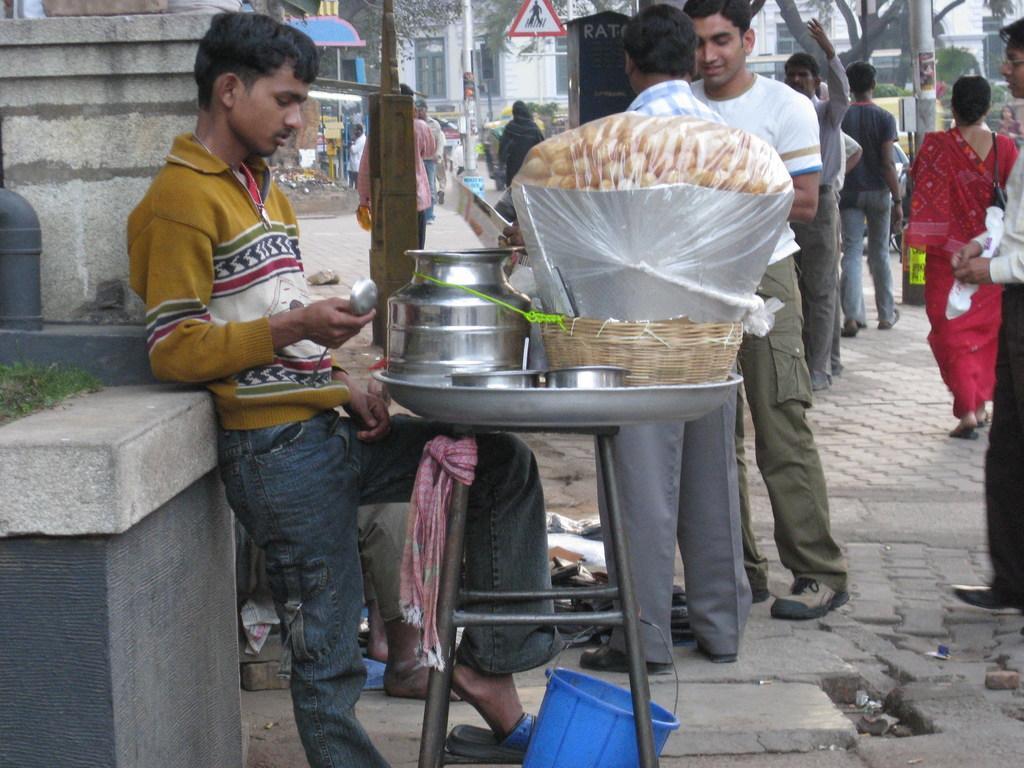Please provide a concise description of this image. In the foreground of the picture there is a person, in front of him there is a table, on the table there are bowls, basket, food items and other objects. At the bottom there is a basket. In the center of the picture there are people, trees, boards on the footpath. In the background there are buildings, trees, people and many other objects. On the left there is wall. 